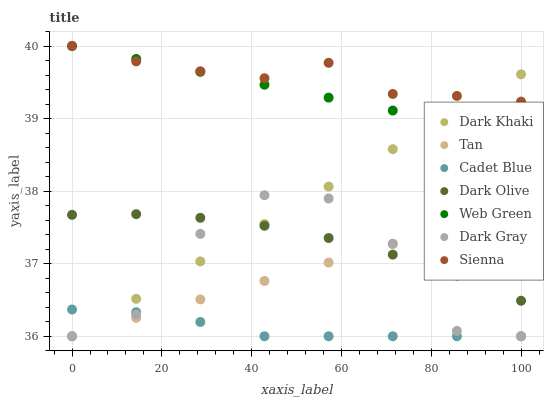Does Cadet Blue have the minimum area under the curve?
Answer yes or no. Yes. Does Sienna have the maximum area under the curve?
Answer yes or no. Yes. Does Dark Olive have the minimum area under the curve?
Answer yes or no. No. Does Dark Olive have the maximum area under the curve?
Answer yes or no. No. Is Web Green the smoothest?
Answer yes or no. Yes. Is Dark Gray the roughest?
Answer yes or no. Yes. Is Cadet Blue the smoothest?
Answer yes or no. No. Is Cadet Blue the roughest?
Answer yes or no. No. Does Dark Gray have the lowest value?
Answer yes or no. Yes. Does Dark Olive have the lowest value?
Answer yes or no. No. Does Sienna have the highest value?
Answer yes or no. Yes. Does Dark Olive have the highest value?
Answer yes or no. No. Is Cadet Blue less than Dark Olive?
Answer yes or no. Yes. Is Sienna greater than Tan?
Answer yes or no. Yes. Does Cadet Blue intersect Dark Gray?
Answer yes or no. Yes. Is Cadet Blue less than Dark Gray?
Answer yes or no. No. Is Cadet Blue greater than Dark Gray?
Answer yes or no. No. Does Cadet Blue intersect Dark Olive?
Answer yes or no. No. 